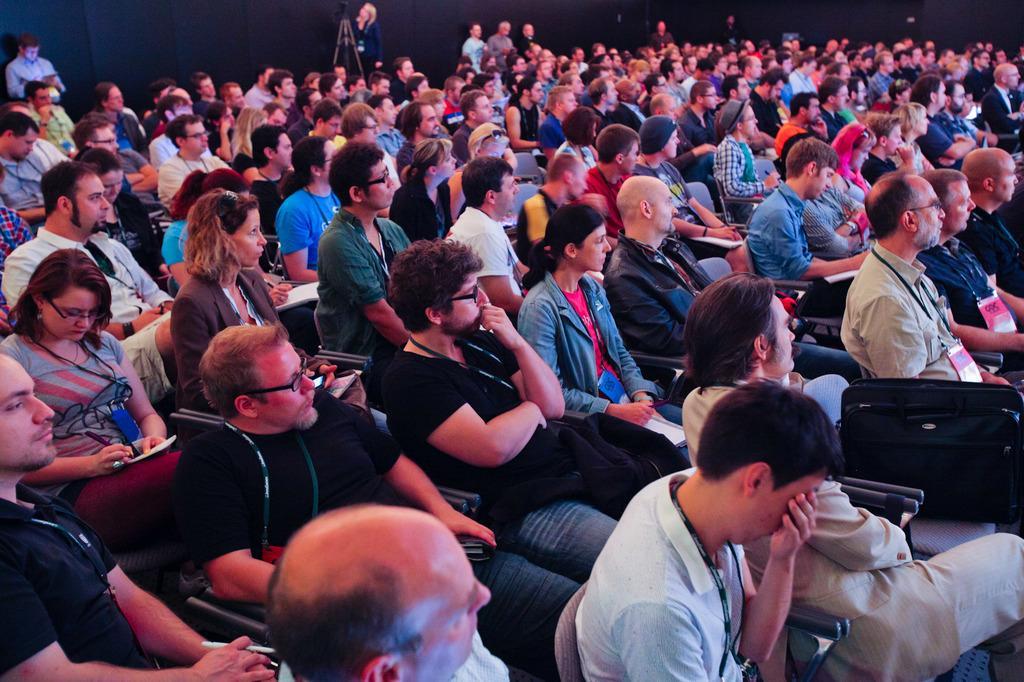Please provide a concise description of this image. In this picture I can observe some people sitting in the chairs. There are men and women in this picture. Some of them are wearing spectacles. In the background I can observe a tripod stand and a wall. 